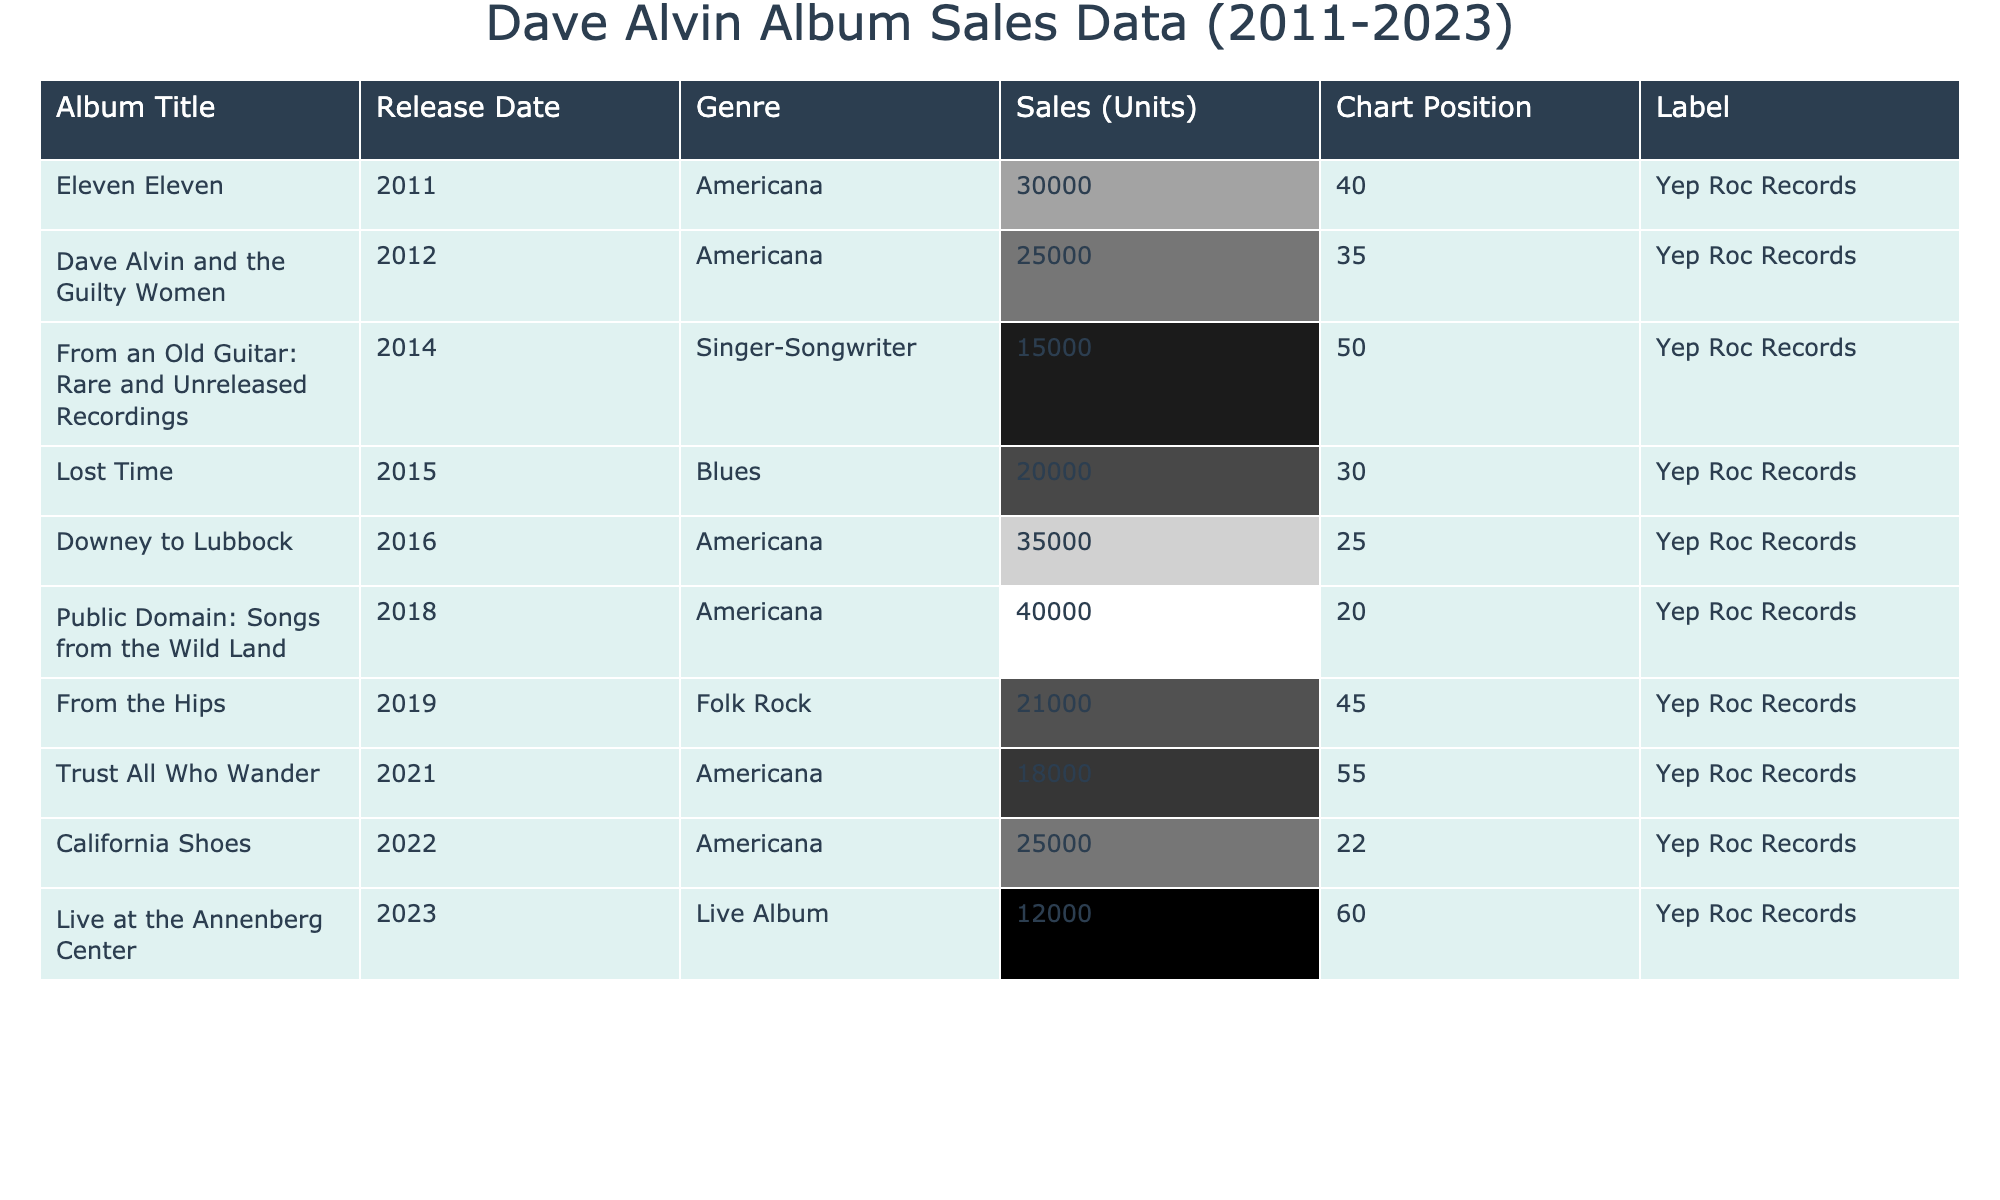What is the title of Dave Alvin's album with the highest sales? By examining the sales figures, "Public Domain: Songs from the Wild Land" has the highest sales at 40,000 units.
Answer: Public Domain: Songs from the Wild Land Which album was released in 2015? The album "Lost Time" was released in 2015, as indicated by its release date.
Answer: Lost Time What are the total sales of all albums combined from 2011 to 2023? To find the total, we sum all the sales: 30000 + 25000 + 15000 + 20000 + 35000 + 40000 + 21000 + 18000 + 25000 + 12000 = 218000.
Answer: 218000 Is "California Shoes" ranked higher than "Lost Time" in chart position? "California Shoes" is at position 22, while "Lost Time" is at position 30, indicating that "California Shoes" is ranked higher.
Answer: Yes What is the average sales of Dave Alvin's albums released between 2011 and 2017? The albums released in that timeframe are: "Eleven Eleven" (30000), "Dave Alvin and the Guilty Women" (25000), "From an Old Guitar" (15000), "Lost Time" (20000), "Downey to Lubbock" (35000). Summing these gives 30000 + 25000 + 15000 + 20000 + 35000 = 125000. Dividing by 5 gives an average of 125000 / 5 = 25000.
Answer: 25000 Which album has the lowest sales and what are its sales figures? The album "Live at the Annenberg Center" has the lowest sales at 12,000 units, which can be noted from the sales figures.
Answer: 12000 Are all of Dave Alvin's albums released in the last decade under the same label? All albums listed are under "Yep Roc Records," indicating they all share the same label.
Answer: Yes What was the sales difference between "Public Domain: Songs from the Wild Land" and "Trust All Who Wander"? "Public Domain: Songs from the Wild Land" sold 40,000 units, and "Trust All Who Wander" sold 18,000. The difference is 40000 - 18000 = 22000.
Answer: 22000 How many albums from the list were released after 2018? The albums released after 2018 are: "From the Hips" (2019), "Trust All Who Wander" (2021), "California Shoes" (2022), and "Live at the Annenberg Center" (2023). This totals four albums.
Answer: 4 What genre is the album "From an Old Guitar: Rare and Unreleased Recordings"? The genre of "From an Old Guitar: Rare and Unreleased Recordings" is listed as "Singer-Songwriter" in the table.
Answer: Singer-Songwriter What percentage of total album sales does "Downey to Lubbock" represent? "Downey to Lubbock" has 35,000 sales. The total sales of all albums is 218,000. The percentage is calculated as (35000 / 218000) * 100 = 16.06%.
Answer: 16.06% 